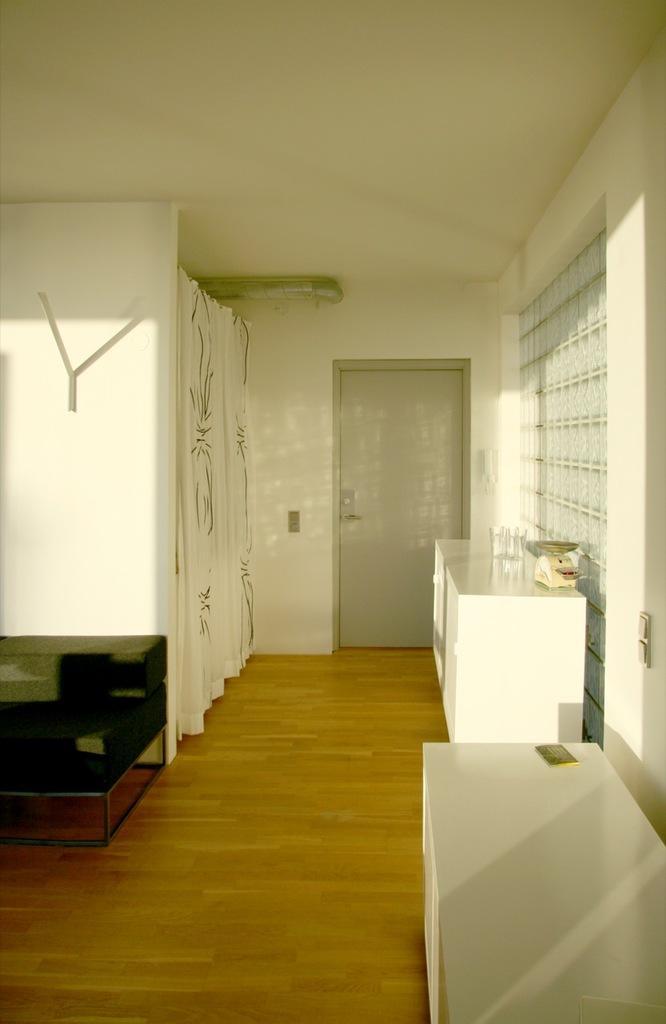Can you describe this image briefly? This image consists of a house. In the front, we can see a door along with wall. At the bottom, there is a floor. On the left, there is a curtain. At the top, there is a roof. On the right, we can see the cabinets. 